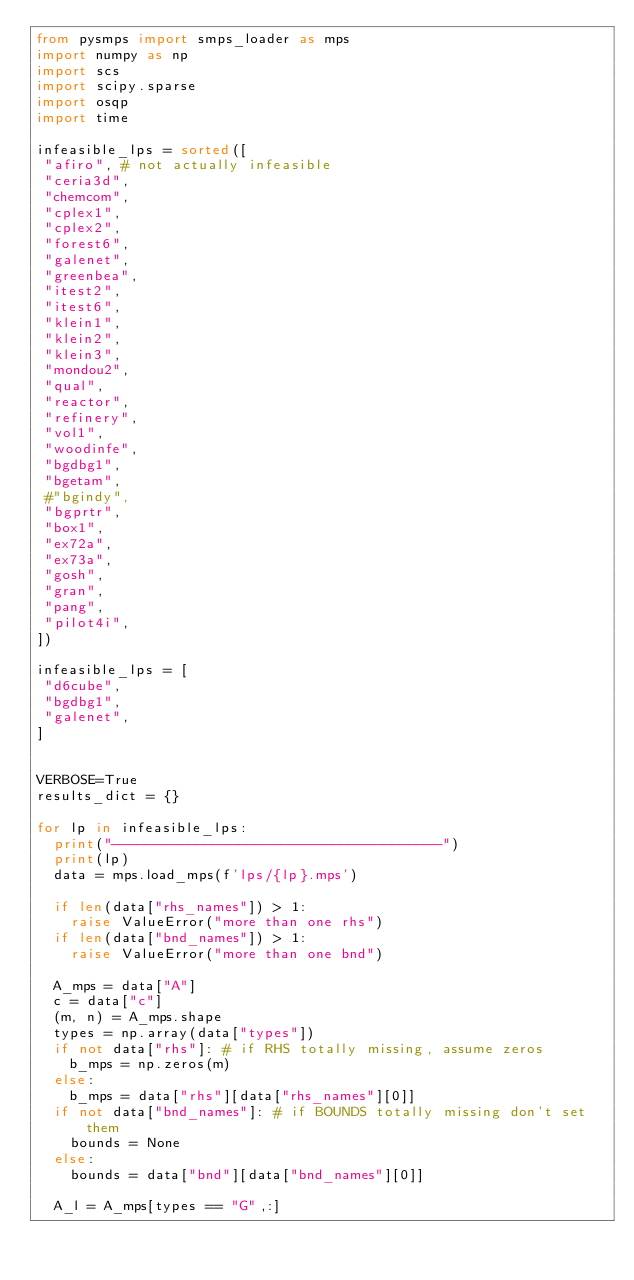Convert code to text. <code><loc_0><loc_0><loc_500><loc_500><_Python_>from pysmps import smps_loader as mps
import numpy as np
import scs
import scipy.sparse
import osqp
import time

infeasible_lps = sorted([
 "afiro", # not actually infeasible
 "ceria3d",
 "chemcom",
 "cplex1",
 "cplex2",
 "forest6",
 "galenet",
 "greenbea",
 "itest2",
 "itest6",
 "klein1",
 "klein2",
 "klein3",
 "mondou2",
 "qual",
 "reactor",
 "refinery",
 "vol1",
 "woodinfe",
 "bgdbg1",
 "bgetam",
 #"bgindy",
 "bgprtr",
 "box1",
 "ex72a",
 "ex73a",
 "gosh",
 "gran",
 "pang",
 "pilot4i",
])

infeasible_lps = [
 "d6cube",
 "bgdbg1",
 "galenet",
]


VERBOSE=True
results_dict = {}

for lp in infeasible_lps:
  print("---------------------------------------")
  print(lp)
  data = mps.load_mps(f'lps/{lp}.mps')

  if len(data["rhs_names"]) > 1:
    raise ValueError("more than one rhs")
  if len(data["bnd_names"]) > 1:
    raise ValueError("more than one bnd")

  A_mps = data["A"]
  c = data["c"]
  (m, n) = A_mps.shape
  types = np.array(data["types"])
  if not data["rhs"]: # if RHS totally missing, assume zeros
    b_mps = np.zeros(m)
  else:
    b_mps = data["rhs"][data["rhs_names"][0]]
  if not data["bnd_names"]: # if BOUNDS totally missing don't set them
    bounds = None
  else:
    bounds = data["bnd"][data["bnd_names"][0]]

  A_l = A_mps[types == "G",:]</code> 